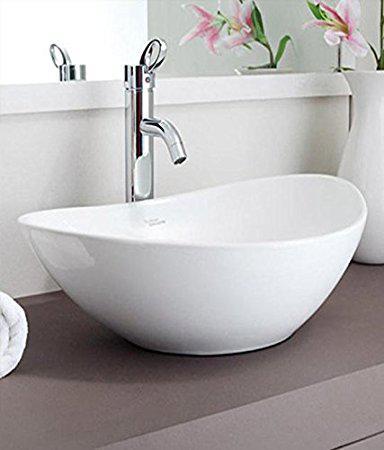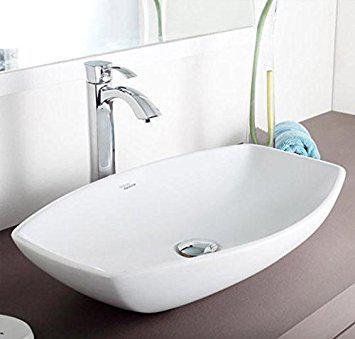The first image is the image on the left, the second image is the image on the right. Examine the images to the left and right. Is the description "The two images show a somewhat round bowl sink and a rectangular inset sink." accurate? Answer yes or no. No. 